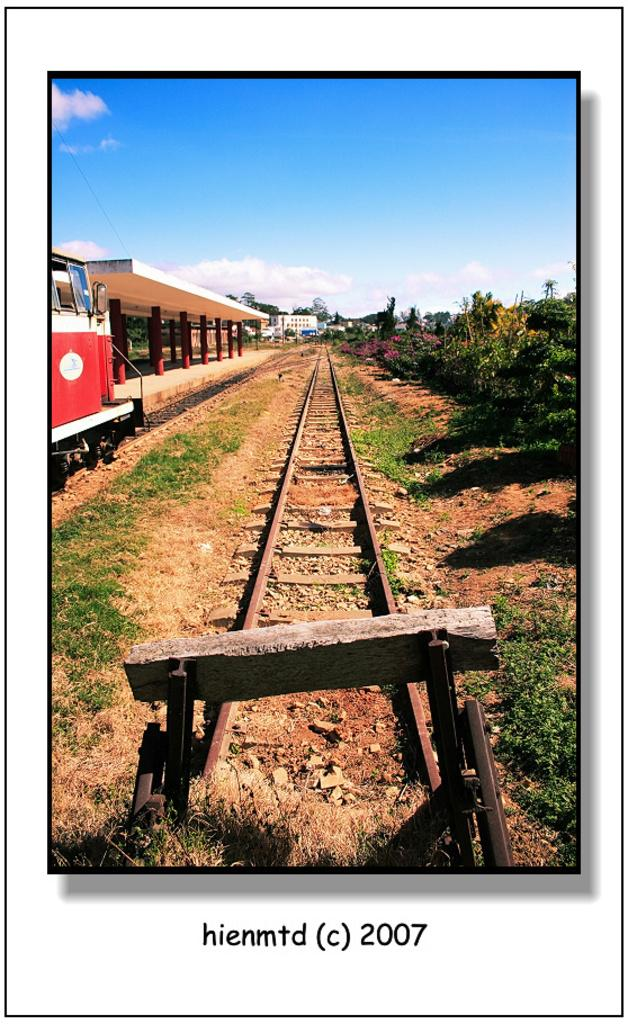<image>
Give a short and clear explanation of the subsequent image. Train tracks are in a picture with hiemtd 2007 at the bottom. 